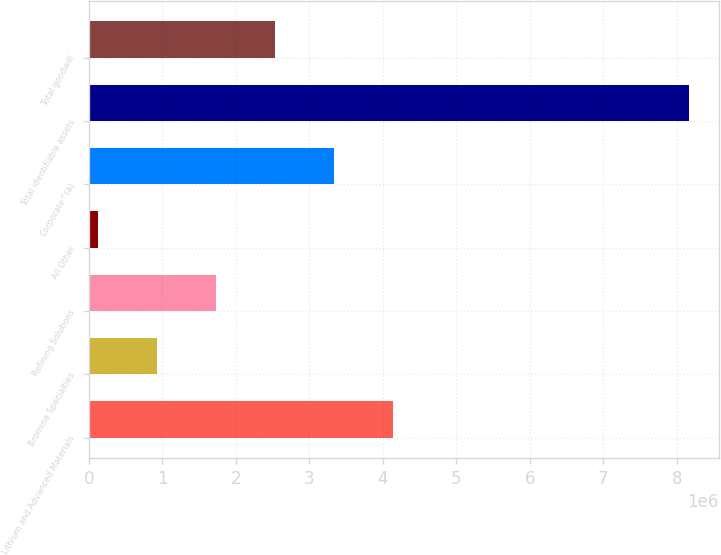<chart> <loc_0><loc_0><loc_500><loc_500><bar_chart><fcel>Lithium and Advanced Materials<fcel>Bromine Specialties<fcel>Refining Solutions<fcel>All Other<fcel>Corporate^(a)<fcel>Total identifiable assets<fcel>Total goodwill<nl><fcel>4.1459e+06<fcel>933656<fcel>1.73672e+06<fcel>130595<fcel>3.34284e+06<fcel>8.16121e+06<fcel>2.53978e+06<nl></chart> 